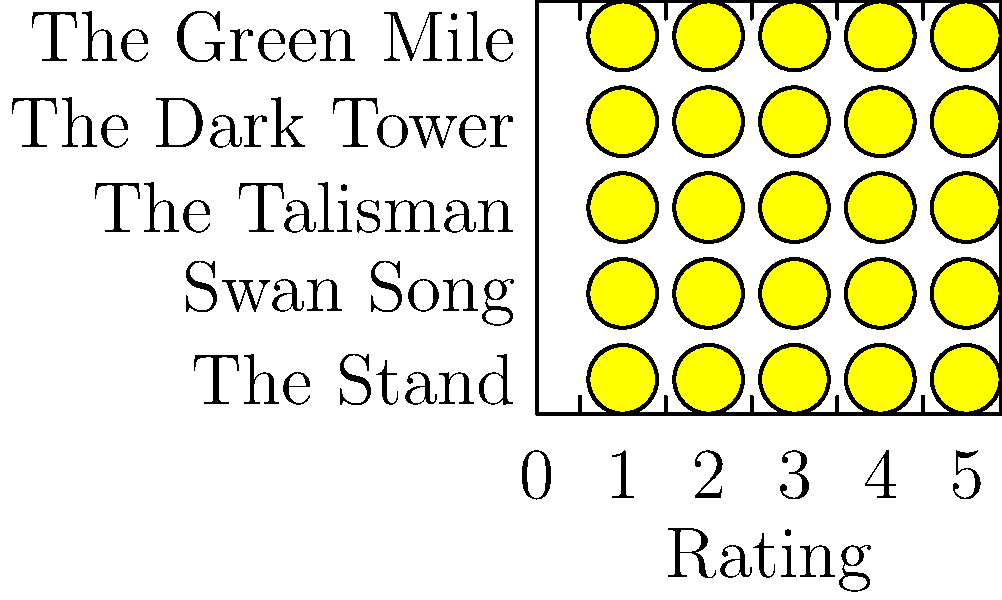Based on the star ratings shown for Frank Muller's top 5 audiobook narrations, which book has the highest rating and how many full stars does it receive? To answer this question, we need to follow these steps:

1. Examine the graphic, which shows 5 audiobooks narrated by Frank Muller along with their star ratings.

2. The star ratings are represented by filled yellow stars, with partial stars indicating decimal ratings.

3. Count the number of full stars for each book:
   - The Green Mile: 4 full stars
   - The Dark Tower: 4 full stars
   - The Talisman: 4 full stars
   - Swan Song: 4 full stars
   - The Stand: 4 full stars

4. Look at the partial stars to determine which book has the highest overall rating:
   - The Green Mile has the most filled partial star, indicating it has the highest rating.

5. Count the number of full stars for The Green Mile, which is 4.

Therefore, The Green Mile has the highest rating among Frank Muller's top 5 audiobook narrations, and it receives 4 full stars.
Answer: The Green Mile, 4 stars 